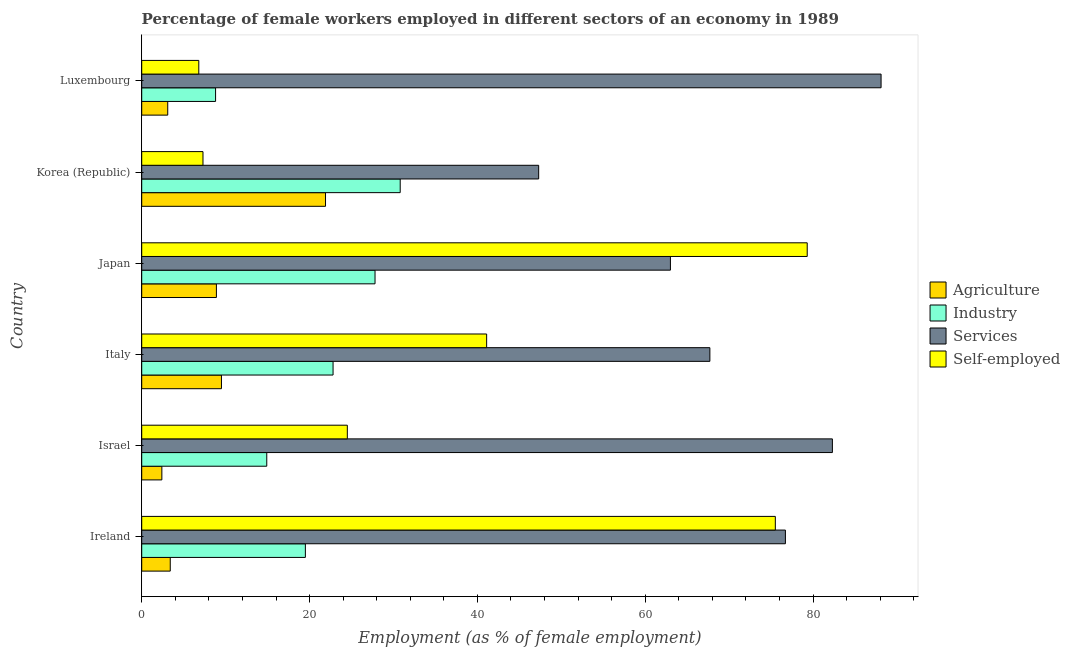How many different coloured bars are there?
Your answer should be compact. 4. Are the number of bars per tick equal to the number of legend labels?
Offer a very short reply. Yes. How many bars are there on the 4th tick from the bottom?
Your answer should be very brief. 4. What is the label of the 6th group of bars from the top?
Your answer should be compact. Ireland. In how many cases, is the number of bars for a given country not equal to the number of legend labels?
Offer a terse response. 0. What is the percentage of self employed female workers in Italy?
Your answer should be compact. 41.1. Across all countries, what is the maximum percentage of female workers in agriculture?
Ensure brevity in your answer.  21.9. Across all countries, what is the minimum percentage of self employed female workers?
Provide a succinct answer. 6.8. In which country was the percentage of female workers in services minimum?
Give a very brief answer. Korea (Republic). What is the total percentage of female workers in services in the graph?
Your answer should be compact. 425.1. What is the difference between the percentage of female workers in services in Luxembourg and the percentage of self employed female workers in Italy?
Your answer should be very brief. 47. What is the average percentage of female workers in services per country?
Your answer should be compact. 70.85. What is the difference between the percentage of female workers in agriculture and percentage of female workers in industry in Israel?
Your answer should be very brief. -12.5. What is the ratio of the percentage of female workers in industry in Ireland to that in Israel?
Your answer should be compact. 1.31. Is the percentage of female workers in agriculture in Ireland less than that in Japan?
Provide a short and direct response. Yes. In how many countries, is the percentage of self employed female workers greater than the average percentage of self employed female workers taken over all countries?
Ensure brevity in your answer.  3. Is it the case that in every country, the sum of the percentage of self employed female workers and percentage of female workers in agriculture is greater than the sum of percentage of female workers in industry and percentage of female workers in services?
Make the answer very short. No. What does the 2nd bar from the top in Japan represents?
Give a very brief answer. Services. What does the 3rd bar from the bottom in Japan represents?
Offer a terse response. Services. Is it the case that in every country, the sum of the percentage of female workers in agriculture and percentage of female workers in industry is greater than the percentage of female workers in services?
Offer a terse response. No. How many bars are there?
Keep it short and to the point. 24. Are the values on the major ticks of X-axis written in scientific E-notation?
Make the answer very short. No. Does the graph contain grids?
Your answer should be compact. No. How many legend labels are there?
Keep it short and to the point. 4. What is the title of the graph?
Your response must be concise. Percentage of female workers employed in different sectors of an economy in 1989. What is the label or title of the X-axis?
Your response must be concise. Employment (as % of female employment). What is the label or title of the Y-axis?
Your answer should be very brief. Country. What is the Employment (as % of female employment) in Agriculture in Ireland?
Ensure brevity in your answer.  3.4. What is the Employment (as % of female employment) in Industry in Ireland?
Give a very brief answer. 19.5. What is the Employment (as % of female employment) in Services in Ireland?
Your answer should be very brief. 76.7. What is the Employment (as % of female employment) of Self-employed in Ireland?
Offer a terse response. 75.5. What is the Employment (as % of female employment) in Agriculture in Israel?
Give a very brief answer. 2.4. What is the Employment (as % of female employment) in Industry in Israel?
Provide a short and direct response. 14.9. What is the Employment (as % of female employment) of Services in Israel?
Your answer should be compact. 82.3. What is the Employment (as % of female employment) of Self-employed in Israel?
Ensure brevity in your answer.  24.5. What is the Employment (as % of female employment) of Industry in Italy?
Provide a succinct answer. 22.8. What is the Employment (as % of female employment) of Services in Italy?
Give a very brief answer. 67.7. What is the Employment (as % of female employment) of Self-employed in Italy?
Your answer should be compact. 41.1. What is the Employment (as % of female employment) in Agriculture in Japan?
Your answer should be compact. 8.9. What is the Employment (as % of female employment) in Industry in Japan?
Your answer should be compact. 27.8. What is the Employment (as % of female employment) of Services in Japan?
Make the answer very short. 63. What is the Employment (as % of female employment) in Self-employed in Japan?
Keep it short and to the point. 79.3. What is the Employment (as % of female employment) in Agriculture in Korea (Republic)?
Ensure brevity in your answer.  21.9. What is the Employment (as % of female employment) in Industry in Korea (Republic)?
Your answer should be compact. 30.8. What is the Employment (as % of female employment) in Services in Korea (Republic)?
Make the answer very short. 47.3. What is the Employment (as % of female employment) of Self-employed in Korea (Republic)?
Make the answer very short. 7.3. What is the Employment (as % of female employment) in Agriculture in Luxembourg?
Keep it short and to the point. 3.1. What is the Employment (as % of female employment) of Industry in Luxembourg?
Provide a succinct answer. 8.8. What is the Employment (as % of female employment) in Services in Luxembourg?
Give a very brief answer. 88.1. What is the Employment (as % of female employment) of Self-employed in Luxembourg?
Make the answer very short. 6.8. Across all countries, what is the maximum Employment (as % of female employment) of Agriculture?
Your answer should be very brief. 21.9. Across all countries, what is the maximum Employment (as % of female employment) in Industry?
Your response must be concise. 30.8. Across all countries, what is the maximum Employment (as % of female employment) of Services?
Keep it short and to the point. 88.1. Across all countries, what is the maximum Employment (as % of female employment) in Self-employed?
Keep it short and to the point. 79.3. Across all countries, what is the minimum Employment (as % of female employment) of Agriculture?
Give a very brief answer. 2.4. Across all countries, what is the minimum Employment (as % of female employment) of Industry?
Provide a succinct answer. 8.8. Across all countries, what is the minimum Employment (as % of female employment) in Services?
Provide a short and direct response. 47.3. Across all countries, what is the minimum Employment (as % of female employment) in Self-employed?
Your response must be concise. 6.8. What is the total Employment (as % of female employment) in Agriculture in the graph?
Keep it short and to the point. 49.2. What is the total Employment (as % of female employment) of Industry in the graph?
Give a very brief answer. 124.6. What is the total Employment (as % of female employment) in Services in the graph?
Your answer should be very brief. 425.1. What is the total Employment (as % of female employment) of Self-employed in the graph?
Provide a short and direct response. 234.5. What is the difference between the Employment (as % of female employment) of Agriculture in Ireland and that in Israel?
Your answer should be compact. 1. What is the difference between the Employment (as % of female employment) in Services in Ireland and that in Israel?
Ensure brevity in your answer.  -5.6. What is the difference between the Employment (as % of female employment) in Agriculture in Ireland and that in Italy?
Your answer should be compact. -6.1. What is the difference between the Employment (as % of female employment) of Industry in Ireland and that in Italy?
Provide a short and direct response. -3.3. What is the difference between the Employment (as % of female employment) of Services in Ireland and that in Italy?
Keep it short and to the point. 9. What is the difference between the Employment (as % of female employment) of Self-employed in Ireland and that in Italy?
Your answer should be compact. 34.4. What is the difference between the Employment (as % of female employment) of Agriculture in Ireland and that in Japan?
Offer a very short reply. -5.5. What is the difference between the Employment (as % of female employment) in Industry in Ireland and that in Japan?
Your response must be concise. -8.3. What is the difference between the Employment (as % of female employment) of Agriculture in Ireland and that in Korea (Republic)?
Provide a succinct answer. -18.5. What is the difference between the Employment (as % of female employment) in Industry in Ireland and that in Korea (Republic)?
Make the answer very short. -11.3. What is the difference between the Employment (as % of female employment) in Services in Ireland and that in Korea (Republic)?
Give a very brief answer. 29.4. What is the difference between the Employment (as % of female employment) in Self-employed in Ireland and that in Korea (Republic)?
Your response must be concise. 68.2. What is the difference between the Employment (as % of female employment) in Industry in Ireland and that in Luxembourg?
Ensure brevity in your answer.  10.7. What is the difference between the Employment (as % of female employment) in Services in Ireland and that in Luxembourg?
Ensure brevity in your answer.  -11.4. What is the difference between the Employment (as % of female employment) in Self-employed in Ireland and that in Luxembourg?
Give a very brief answer. 68.7. What is the difference between the Employment (as % of female employment) of Agriculture in Israel and that in Italy?
Make the answer very short. -7.1. What is the difference between the Employment (as % of female employment) in Self-employed in Israel and that in Italy?
Offer a terse response. -16.6. What is the difference between the Employment (as % of female employment) in Services in Israel and that in Japan?
Offer a terse response. 19.3. What is the difference between the Employment (as % of female employment) of Self-employed in Israel and that in Japan?
Keep it short and to the point. -54.8. What is the difference between the Employment (as % of female employment) in Agriculture in Israel and that in Korea (Republic)?
Provide a short and direct response. -19.5. What is the difference between the Employment (as % of female employment) of Industry in Israel and that in Korea (Republic)?
Offer a terse response. -15.9. What is the difference between the Employment (as % of female employment) of Services in Israel and that in Korea (Republic)?
Your answer should be very brief. 35. What is the difference between the Employment (as % of female employment) of Industry in Israel and that in Luxembourg?
Offer a terse response. 6.1. What is the difference between the Employment (as % of female employment) in Services in Israel and that in Luxembourg?
Keep it short and to the point. -5.8. What is the difference between the Employment (as % of female employment) in Self-employed in Italy and that in Japan?
Ensure brevity in your answer.  -38.2. What is the difference between the Employment (as % of female employment) in Services in Italy and that in Korea (Republic)?
Provide a short and direct response. 20.4. What is the difference between the Employment (as % of female employment) of Self-employed in Italy and that in Korea (Republic)?
Provide a succinct answer. 33.8. What is the difference between the Employment (as % of female employment) in Agriculture in Italy and that in Luxembourg?
Give a very brief answer. 6.4. What is the difference between the Employment (as % of female employment) of Industry in Italy and that in Luxembourg?
Give a very brief answer. 14. What is the difference between the Employment (as % of female employment) of Services in Italy and that in Luxembourg?
Make the answer very short. -20.4. What is the difference between the Employment (as % of female employment) in Self-employed in Italy and that in Luxembourg?
Provide a succinct answer. 34.3. What is the difference between the Employment (as % of female employment) in Industry in Japan and that in Korea (Republic)?
Make the answer very short. -3. What is the difference between the Employment (as % of female employment) of Services in Japan and that in Korea (Republic)?
Provide a short and direct response. 15.7. What is the difference between the Employment (as % of female employment) of Agriculture in Japan and that in Luxembourg?
Offer a terse response. 5.8. What is the difference between the Employment (as % of female employment) in Services in Japan and that in Luxembourg?
Provide a succinct answer. -25.1. What is the difference between the Employment (as % of female employment) of Self-employed in Japan and that in Luxembourg?
Keep it short and to the point. 72.5. What is the difference between the Employment (as % of female employment) of Services in Korea (Republic) and that in Luxembourg?
Provide a short and direct response. -40.8. What is the difference between the Employment (as % of female employment) in Agriculture in Ireland and the Employment (as % of female employment) in Industry in Israel?
Offer a very short reply. -11.5. What is the difference between the Employment (as % of female employment) in Agriculture in Ireland and the Employment (as % of female employment) in Services in Israel?
Your answer should be compact. -78.9. What is the difference between the Employment (as % of female employment) of Agriculture in Ireland and the Employment (as % of female employment) of Self-employed in Israel?
Provide a succinct answer. -21.1. What is the difference between the Employment (as % of female employment) in Industry in Ireland and the Employment (as % of female employment) in Services in Israel?
Ensure brevity in your answer.  -62.8. What is the difference between the Employment (as % of female employment) in Services in Ireland and the Employment (as % of female employment) in Self-employed in Israel?
Make the answer very short. 52.2. What is the difference between the Employment (as % of female employment) of Agriculture in Ireland and the Employment (as % of female employment) of Industry in Italy?
Provide a succinct answer. -19.4. What is the difference between the Employment (as % of female employment) in Agriculture in Ireland and the Employment (as % of female employment) in Services in Italy?
Ensure brevity in your answer.  -64.3. What is the difference between the Employment (as % of female employment) in Agriculture in Ireland and the Employment (as % of female employment) in Self-employed in Italy?
Offer a terse response. -37.7. What is the difference between the Employment (as % of female employment) in Industry in Ireland and the Employment (as % of female employment) in Services in Italy?
Your answer should be compact. -48.2. What is the difference between the Employment (as % of female employment) of Industry in Ireland and the Employment (as % of female employment) of Self-employed in Italy?
Make the answer very short. -21.6. What is the difference between the Employment (as % of female employment) in Services in Ireland and the Employment (as % of female employment) in Self-employed in Italy?
Provide a succinct answer. 35.6. What is the difference between the Employment (as % of female employment) of Agriculture in Ireland and the Employment (as % of female employment) of Industry in Japan?
Your response must be concise. -24.4. What is the difference between the Employment (as % of female employment) in Agriculture in Ireland and the Employment (as % of female employment) in Services in Japan?
Make the answer very short. -59.6. What is the difference between the Employment (as % of female employment) in Agriculture in Ireland and the Employment (as % of female employment) in Self-employed in Japan?
Keep it short and to the point. -75.9. What is the difference between the Employment (as % of female employment) in Industry in Ireland and the Employment (as % of female employment) in Services in Japan?
Your response must be concise. -43.5. What is the difference between the Employment (as % of female employment) in Industry in Ireland and the Employment (as % of female employment) in Self-employed in Japan?
Offer a very short reply. -59.8. What is the difference between the Employment (as % of female employment) of Services in Ireland and the Employment (as % of female employment) of Self-employed in Japan?
Your answer should be very brief. -2.6. What is the difference between the Employment (as % of female employment) in Agriculture in Ireland and the Employment (as % of female employment) in Industry in Korea (Republic)?
Offer a terse response. -27.4. What is the difference between the Employment (as % of female employment) of Agriculture in Ireland and the Employment (as % of female employment) of Services in Korea (Republic)?
Keep it short and to the point. -43.9. What is the difference between the Employment (as % of female employment) in Industry in Ireland and the Employment (as % of female employment) in Services in Korea (Republic)?
Provide a short and direct response. -27.8. What is the difference between the Employment (as % of female employment) of Services in Ireland and the Employment (as % of female employment) of Self-employed in Korea (Republic)?
Your answer should be compact. 69.4. What is the difference between the Employment (as % of female employment) in Agriculture in Ireland and the Employment (as % of female employment) in Services in Luxembourg?
Give a very brief answer. -84.7. What is the difference between the Employment (as % of female employment) of Agriculture in Ireland and the Employment (as % of female employment) of Self-employed in Luxembourg?
Make the answer very short. -3.4. What is the difference between the Employment (as % of female employment) in Industry in Ireland and the Employment (as % of female employment) in Services in Luxembourg?
Ensure brevity in your answer.  -68.6. What is the difference between the Employment (as % of female employment) of Industry in Ireland and the Employment (as % of female employment) of Self-employed in Luxembourg?
Keep it short and to the point. 12.7. What is the difference between the Employment (as % of female employment) in Services in Ireland and the Employment (as % of female employment) in Self-employed in Luxembourg?
Give a very brief answer. 69.9. What is the difference between the Employment (as % of female employment) in Agriculture in Israel and the Employment (as % of female employment) in Industry in Italy?
Provide a short and direct response. -20.4. What is the difference between the Employment (as % of female employment) of Agriculture in Israel and the Employment (as % of female employment) of Services in Italy?
Your answer should be very brief. -65.3. What is the difference between the Employment (as % of female employment) in Agriculture in Israel and the Employment (as % of female employment) in Self-employed in Italy?
Offer a very short reply. -38.7. What is the difference between the Employment (as % of female employment) of Industry in Israel and the Employment (as % of female employment) of Services in Italy?
Provide a succinct answer. -52.8. What is the difference between the Employment (as % of female employment) of Industry in Israel and the Employment (as % of female employment) of Self-employed in Italy?
Make the answer very short. -26.2. What is the difference between the Employment (as % of female employment) in Services in Israel and the Employment (as % of female employment) in Self-employed in Italy?
Give a very brief answer. 41.2. What is the difference between the Employment (as % of female employment) of Agriculture in Israel and the Employment (as % of female employment) of Industry in Japan?
Offer a terse response. -25.4. What is the difference between the Employment (as % of female employment) of Agriculture in Israel and the Employment (as % of female employment) of Services in Japan?
Your answer should be compact. -60.6. What is the difference between the Employment (as % of female employment) in Agriculture in Israel and the Employment (as % of female employment) in Self-employed in Japan?
Provide a succinct answer. -76.9. What is the difference between the Employment (as % of female employment) of Industry in Israel and the Employment (as % of female employment) of Services in Japan?
Your response must be concise. -48.1. What is the difference between the Employment (as % of female employment) in Industry in Israel and the Employment (as % of female employment) in Self-employed in Japan?
Offer a terse response. -64.4. What is the difference between the Employment (as % of female employment) in Services in Israel and the Employment (as % of female employment) in Self-employed in Japan?
Ensure brevity in your answer.  3. What is the difference between the Employment (as % of female employment) in Agriculture in Israel and the Employment (as % of female employment) in Industry in Korea (Republic)?
Make the answer very short. -28.4. What is the difference between the Employment (as % of female employment) in Agriculture in Israel and the Employment (as % of female employment) in Services in Korea (Republic)?
Give a very brief answer. -44.9. What is the difference between the Employment (as % of female employment) in Agriculture in Israel and the Employment (as % of female employment) in Self-employed in Korea (Republic)?
Provide a succinct answer. -4.9. What is the difference between the Employment (as % of female employment) of Industry in Israel and the Employment (as % of female employment) of Services in Korea (Republic)?
Ensure brevity in your answer.  -32.4. What is the difference between the Employment (as % of female employment) of Industry in Israel and the Employment (as % of female employment) of Self-employed in Korea (Republic)?
Your answer should be very brief. 7.6. What is the difference between the Employment (as % of female employment) of Services in Israel and the Employment (as % of female employment) of Self-employed in Korea (Republic)?
Your answer should be very brief. 75. What is the difference between the Employment (as % of female employment) of Agriculture in Israel and the Employment (as % of female employment) of Industry in Luxembourg?
Give a very brief answer. -6.4. What is the difference between the Employment (as % of female employment) of Agriculture in Israel and the Employment (as % of female employment) of Services in Luxembourg?
Offer a very short reply. -85.7. What is the difference between the Employment (as % of female employment) in Industry in Israel and the Employment (as % of female employment) in Services in Luxembourg?
Your response must be concise. -73.2. What is the difference between the Employment (as % of female employment) in Services in Israel and the Employment (as % of female employment) in Self-employed in Luxembourg?
Ensure brevity in your answer.  75.5. What is the difference between the Employment (as % of female employment) of Agriculture in Italy and the Employment (as % of female employment) of Industry in Japan?
Ensure brevity in your answer.  -18.3. What is the difference between the Employment (as % of female employment) of Agriculture in Italy and the Employment (as % of female employment) of Services in Japan?
Keep it short and to the point. -53.5. What is the difference between the Employment (as % of female employment) of Agriculture in Italy and the Employment (as % of female employment) of Self-employed in Japan?
Keep it short and to the point. -69.8. What is the difference between the Employment (as % of female employment) in Industry in Italy and the Employment (as % of female employment) in Services in Japan?
Give a very brief answer. -40.2. What is the difference between the Employment (as % of female employment) in Industry in Italy and the Employment (as % of female employment) in Self-employed in Japan?
Give a very brief answer. -56.5. What is the difference between the Employment (as % of female employment) of Agriculture in Italy and the Employment (as % of female employment) of Industry in Korea (Republic)?
Your answer should be very brief. -21.3. What is the difference between the Employment (as % of female employment) in Agriculture in Italy and the Employment (as % of female employment) in Services in Korea (Republic)?
Keep it short and to the point. -37.8. What is the difference between the Employment (as % of female employment) of Agriculture in Italy and the Employment (as % of female employment) of Self-employed in Korea (Republic)?
Make the answer very short. 2.2. What is the difference between the Employment (as % of female employment) of Industry in Italy and the Employment (as % of female employment) of Services in Korea (Republic)?
Provide a succinct answer. -24.5. What is the difference between the Employment (as % of female employment) in Industry in Italy and the Employment (as % of female employment) in Self-employed in Korea (Republic)?
Offer a terse response. 15.5. What is the difference between the Employment (as % of female employment) of Services in Italy and the Employment (as % of female employment) of Self-employed in Korea (Republic)?
Your answer should be very brief. 60.4. What is the difference between the Employment (as % of female employment) of Agriculture in Italy and the Employment (as % of female employment) of Industry in Luxembourg?
Offer a very short reply. 0.7. What is the difference between the Employment (as % of female employment) in Agriculture in Italy and the Employment (as % of female employment) in Services in Luxembourg?
Offer a very short reply. -78.6. What is the difference between the Employment (as % of female employment) of Agriculture in Italy and the Employment (as % of female employment) of Self-employed in Luxembourg?
Ensure brevity in your answer.  2.7. What is the difference between the Employment (as % of female employment) in Industry in Italy and the Employment (as % of female employment) in Services in Luxembourg?
Offer a very short reply. -65.3. What is the difference between the Employment (as % of female employment) of Services in Italy and the Employment (as % of female employment) of Self-employed in Luxembourg?
Make the answer very short. 60.9. What is the difference between the Employment (as % of female employment) in Agriculture in Japan and the Employment (as % of female employment) in Industry in Korea (Republic)?
Your answer should be very brief. -21.9. What is the difference between the Employment (as % of female employment) of Agriculture in Japan and the Employment (as % of female employment) of Services in Korea (Republic)?
Provide a succinct answer. -38.4. What is the difference between the Employment (as % of female employment) of Industry in Japan and the Employment (as % of female employment) of Services in Korea (Republic)?
Provide a short and direct response. -19.5. What is the difference between the Employment (as % of female employment) of Industry in Japan and the Employment (as % of female employment) of Self-employed in Korea (Republic)?
Offer a very short reply. 20.5. What is the difference between the Employment (as % of female employment) in Services in Japan and the Employment (as % of female employment) in Self-employed in Korea (Republic)?
Keep it short and to the point. 55.7. What is the difference between the Employment (as % of female employment) in Agriculture in Japan and the Employment (as % of female employment) in Industry in Luxembourg?
Your answer should be very brief. 0.1. What is the difference between the Employment (as % of female employment) of Agriculture in Japan and the Employment (as % of female employment) of Services in Luxembourg?
Your answer should be compact. -79.2. What is the difference between the Employment (as % of female employment) in Industry in Japan and the Employment (as % of female employment) in Services in Luxembourg?
Your answer should be very brief. -60.3. What is the difference between the Employment (as % of female employment) of Services in Japan and the Employment (as % of female employment) of Self-employed in Luxembourg?
Provide a succinct answer. 56.2. What is the difference between the Employment (as % of female employment) in Agriculture in Korea (Republic) and the Employment (as % of female employment) in Services in Luxembourg?
Keep it short and to the point. -66.2. What is the difference between the Employment (as % of female employment) in Industry in Korea (Republic) and the Employment (as % of female employment) in Services in Luxembourg?
Keep it short and to the point. -57.3. What is the difference between the Employment (as % of female employment) of Industry in Korea (Republic) and the Employment (as % of female employment) of Self-employed in Luxembourg?
Your answer should be very brief. 24. What is the difference between the Employment (as % of female employment) of Services in Korea (Republic) and the Employment (as % of female employment) of Self-employed in Luxembourg?
Give a very brief answer. 40.5. What is the average Employment (as % of female employment) in Agriculture per country?
Your answer should be compact. 8.2. What is the average Employment (as % of female employment) in Industry per country?
Offer a terse response. 20.77. What is the average Employment (as % of female employment) in Services per country?
Offer a terse response. 70.85. What is the average Employment (as % of female employment) in Self-employed per country?
Offer a terse response. 39.08. What is the difference between the Employment (as % of female employment) of Agriculture and Employment (as % of female employment) of Industry in Ireland?
Give a very brief answer. -16.1. What is the difference between the Employment (as % of female employment) in Agriculture and Employment (as % of female employment) in Services in Ireland?
Give a very brief answer. -73.3. What is the difference between the Employment (as % of female employment) of Agriculture and Employment (as % of female employment) of Self-employed in Ireland?
Make the answer very short. -72.1. What is the difference between the Employment (as % of female employment) in Industry and Employment (as % of female employment) in Services in Ireland?
Make the answer very short. -57.2. What is the difference between the Employment (as % of female employment) of Industry and Employment (as % of female employment) of Self-employed in Ireland?
Offer a very short reply. -56. What is the difference between the Employment (as % of female employment) in Agriculture and Employment (as % of female employment) in Services in Israel?
Keep it short and to the point. -79.9. What is the difference between the Employment (as % of female employment) of Agriculture and Employment (as % of female employment) of Self-employed in Israel?
Your answer should be very brief. -22.1. What is the difference between the Employment (as % of female employment) in Industry and Employment (as % of female employment) in Services in Israel?
Keep it short and to the point. -67.4. What is the difference between the Employment (as % of female employment) in Industry and Employment (as % of female employment) in Self-employed in Israel?
Provide a succinct answer. -9.6. What is the difference between the Employment (as % of female employment) in Services and Employment (as % of female employment) in Self-employed in Israel?
Offer a very short reply. 57.8. What is the difference between the Employment (as % of female employment) in Agriculture and Employment (as % of female employment) in Industry in Italy?
Ensure brevity in your answer.  -13.3. What is the difference between the Employment (as % of female employment) in Agriculture and Employment (as % of female employment) in Services in Italy?
Your response must be concise. -58.2. What is the difference between the Employment (as % of female employment) of Agriculture and Employment (as % of female employment) of Self-employed in Italy?
Give a very brief answer. -31.6. What is the difference between the Employment (as % of female employment) of Industry and Employment (as % of female employment) of Services in Italy?
Give a very brief answer. -44.9. What is the difference between the Employment (as % of female employment) of Industry and Employment (as % of female employment) of Self-employed in Italy?
Offer a terse response. -18.3. What is the difference between the Employment (as % of female employment) in Services and Employment (as % of female employment) in Self-employed in Italy?
Provide a succinct answer. 26.6. What is the difference between the Employment (as % of female employment) of Agriculture and Employment (as % of female employment) of Industry in Japan?
Your answer should be compact. -18.9. What is the difference between the Employment (as % of female employment) in Agriculture and Employment (as % of female employment) in Services in Japan?
Give a very brief answer. -54.1. What is the difference between the Employment (as % of female employment) in Agriculture and Employment (as % of female employment) in Self-employed in Japan?
Keep it short and to the point. -70.4. What is the difference between the Employment (as % of female employment) of Industry and Employment (as % of female employment) of Services in Japan?
Provide a succinct answer. -35.2. What is the difference between the Employment (as % of female employment) in Industry and Employment (as % of female employment) in Self-employed in Japan?
Make the answer very short. -51.5. What is the difference between the Employment (as % of female employment) in Services and Employment (as % of female employment) in Self-employed in Japan?
Keep it short and to the point. -16.3. What is the difference between the Employment (as % of female employment) of Agriculture and Employment (as % of female employment) of Industry in Korea (Republic)?
Your answer should be compact. -8.9. What is the difference between the Employment (as % of female employment) of Agriculture and Employment (as % of female employment) of Services in Korea (Republic)?
Provide a succinct answer. -25.4. What is the difference between the Employment (as % of female employment) of Agriculture and Employment (as % of female employment) of Self-employed in Korea (Republic)?
Your answer should be very brief. 14.6. What is the difference between the Employment (as % of female employment) in Industry and Employment (as % of female employment) in Services in Korea (Republic)?
Offer a very short reply. -16.5. What is the difference between the Employment (as % of female employment) in Industry and Employment (as % of female employment) in Self-employed in Korea (Republic)?
Offer a very short reply. 23.5. What is the difference between the Employment (as % of female employment) of Agriculture and Employment (as % of female employment) of Industry in Luxembourg?
Offer a terse response. -5.7. What is the difference between the Employment (as % of female employment) of Agriculture and Employment (as % of female employment) of Services in Luxembourg?
Provide a succinct answer. -85. What is the difference between the Employment (as % of female employment) of Industry and Employment (as % of female employment) of Services in Luxembourg?
Keep it short and to the point. -79.3. What is the difference between the Employment (as % of female employment) in Services and Employment (as % of female employment) in Self-employed in Luxembourg?
Give a very brief answer. 81.3. What is the ratio of the Employment (as % of female employment) of Agriculture in Ireland to that in Israel?
Your answer should be compact. 1.42. What is the ratio of the Employment (as % of female employment) in Industry in Ireland to that in Israel?
Keep it short and to the point. 1.31. What is the ratio of the Employment (as % of female employment) of Services in Ireland to that in Israel?
Provide a succinct answer. 0.93. What is the ratio of the Employment (as % of female employment) in Self-employed in Ireland to that in Israel?
Your answer should be very brief. 3.08. What is the ratio of the Employment (as % of female employment) in Agriculture in Ireland to that in Italy?
Your answer should be compact. 0.36. What is the ratio of the Employment (as % of female employment) of Industry in Ireland to that in Italy?
Give a very brief answer. 0.86. What is the ratio of the Employment (as % of female employment) in Services in Ireland to that in Italy?
Offer a very short reply. 1.13. What is the ratio of the Employment (as % of female employment) in Self-employed in Ireland to that in Italy?
Provide a succinct answer. 1.84. What is the ratio of the Employment (as % of female employment) of Agriculture in Ireland to that in Japan?
Keep it short and to the point. 0.38. What is the ratio of the Employment (as % of female employment) in Industry in Ireland to that in Japan?
Provide a short and direct response. 0.7. What is the ratio of the Employment (as % of female employment) of Services in Ireland to that in Japan?
Provide a short and direct response. 1.22. What is the ratio of the Employment (as % of female employment) in Self-employed in Ireland to that in Japan?
Offer a terse response. 0.95. What is the ratio of the Employment (as % of female employment) in Agriculture in Ireland to that in Korea (Republic)?
Your answer should be compact. 0.16. What is the ratio of the Employment (as % of female employment) of Industry in Ireland to that in Korea (Republic)?
Offer a terse response. 0.63. What is the ratio of the Employment (as % of female employment) in Services in Ireland to that in Korea (Republic)?
Give a very brief answer. 1.62. What is the ratio of the Employment (as % of female employment) of Self-employed in Ireland to that in Korea (Republic)?
Your answer should be very brief. 10.34. What is the ratio of the Employment (as % of female employment) in Agriculture in Ireland to that in Luxembourg?
Provide a short and direct response. 1.1. What is the ratio of the Employment (as % of female employment) in Industry in Ireland to that in Luxembourg?
Keep it short and to the point. 2.22. What is the ratio of the Employment (as % of female employment) in Services in Ireland to that in Luxembourg?
Your response must be concise. 0.87. What is the ratio of the Employment (as % of female employment) of Self-employed in Ireland to that in Luxembourg?
Offer a very short reply. 11.1. What is the ratio of the Employment (as % of female employment) in Agriculture in Israel to that in Italy?
Provide a succinct answer. 0.25. What is the ratio of the Employment (as % of female employment) of Industry in Israel to that in Italy?
Your answer should be very brief. 0.65. What is the ratio of the Employment (as % of female employment) in Services in Israel to that in Italy?
Make the answer very short. 1.22. What is the ratio of the Employment (as % of female employment) in Self-employed in Israel to that in Italy?
Ensure brevity in your answer.  0.6. What is the ratio of the Employment (as % of female employment) of Agriculture in Israel to that in Japan?
Your answer should be very brief. 0.27. What is the ratio of the Employment (as % of female employment) in Industry in Israel to that in Japan?
Give a very brief answer. 0.54. What is the ratio of the Employment (as % of female employment) of Services in Israel to that in Japan?
Offer a terse response. 1.31. What is the ratio of the Employment (as % of female employment) of Self-employed in Israel to that in Japan?
Make the answer very short. 0.31. What is the ratio of the Employment (as % of female employment) in Agriculture in Israel to that in Korea (Republic)?
Your answer should be very brief. 0.11. What is the ratio of the Employment (as % of female employment) of Industry in Israel to that in Korea (Republic)?
Ensure brevity in your answer.  0.48. What is the ratio of the Employment (as % of female employment) in Services in Israel to that in Korea (Republic)?
Make the answer very short. 1.74. What is the ratio of the Employment (as % of female employment) in Self-employed in Israel to that in Korea (Republic)?
Give a very brief answer. 3.36. What is the ratio of the Employment (as % of female employment) of Agriculture in Israel to that in Luxembourg?
Offer a terse response. 0.77. What is the ratio of the Employment (as % of female employment) in Industry in Israel to that in Luxembourg?
Offer a very short reply. 1.69. What is the ratio of the Employment (as % of female employment) of Services in Israel to that in Luxembourg?
Offer a very short reply. 0.93. What is the ratio of the Employment (as % of female employment) in Self-employed in Israel to that in Luxembourg?
Ensure brevity in your answer.  3.6. What is the ratio of the Employment (as % of female employment) in Agriculture in Italy to that in Japan?
Your answer should be very brief. 1.07. What is the ratio of the Employment (as % of female employment) of Industry in Italy to that in Japan?
Make the answer very short. 0.82. What is the ratio of the Employment (as % of female employment) in Services in Italy to that in Japan?
Make the answer very short. 1.07. What is the ratio of the Employment (as % of female employment) in Self-employed in Italy to that in Japan?
Ensure brevity in your answer.  0.52. What is the ratio of the Employment (as % of female employment) of Agriculture in Italy to that in Korea (Republic)?
Offer a very short reply. 0.43. What is the ratio of the Employment (as % of female employment) in Industry in Italy to that in Korea (Republic)?
Provide a short and direct response. 0.74. What is the ratio of the Employment (as % of female employment) of Services in Italy to that in Korea (Republic)?
Give a very brief answer. 1.43. What is the ratio of the Employment (as % of female employment) of Self-employed in Italy to that in Korea (Republic)?
Give a very brief answer. 5.63. What is the ratio of the Employment (as % of female employment) in Agriculture in Italy to that in Luxembourg?
Give a very brief answer. 3.06. What is the ratio of the Employment (as % of female employment) in Industry in Italy to that in Luxembourg?
Make the answer very short. 2.59. What is the ratio of the Employment (as % of female employment) in Services in Italy to that in Luxembourg?
Provide a succinct answer. 0.77. What is the ratio of the Employment (as % of female employment) of Self-employed in Italy to that in Luxembourg?
Make the answer very short. 6.04. What is the ratio of the Employment (as % of female employment) in Agriculture in Japan to that in Korea (Republic)?
Ensure brevity in your answer.  0.41. What is the ratio of the Employment (as % of female employment) of Industry in Japan to that in Korea (Republic)?
Your response must be concise. 0.9. What is the ratio of the Employment (as % of female employment) of Services in Japan to that in Korea (Republic)?
Provide a short and direct response. 1.33. What is the ratio of the Employment (as % of female employment) in Self-employed in Japan to that in Korea (Republic)?
Offer a terse response. 10.86. What is the ratio of the Employment (as % of female employment) of Agriculture in Japan to that in Luxembourg?
Your answer should be compact. 2.87. What is the ratio of the Employment (as % of female employment) of Industry in Japan to that in Luxembourg?
Your answer should be very brief. 3.16. What is the ratio of the Employment (as % of female employment) of Services in Japan to that in Luxembourg?
Make the answer very short. 0.72. What is the ratio of the Employment (as % of female employment) in Self-employed in Japan to that in Luxembourg?
Provide a short and direct response. 11.66. What is the ratio of the Employment (as % of female employment) in Agriculture in Korea (Republic) to that in Luxembourg?
Your response must be concise. 7.06. What is the ratio of the Employment (as % of female employment) in Services in Korea (Republic) to that in Luxembourg?
Give a very brief answer. 0.54. What is the ratio of the Employment (as % of female employment) in Self-employed in Korea (Republic) to that in Luxembourg?
Give a very brief answer. 1.07. What is the difference between the highest and the second highest Employment (as % of female employment) in Industry?
Your response must be concise. 3. What is the difference between the highest and the second highest Employment (as % of female employment) in Services?
Give a very brief answer. 5.8. What is the difference between the highest and the second highest Employment (as % of female employment) of Self-employed?
Keep it short and to the point. 3.8. What is the difference between the highest and the lowest Employment (as % of female employment) in Agriculture?
Offer a terse response. 19.5. What is the difference between the highest and the lowest Employment (as % of female employment) in Services?
Provide a succinct answer. 40.8. What is the difference between the highest and the lowest Employment (as % of female employment) of Self-employed?
Your answer should be very brief. 72.5. 